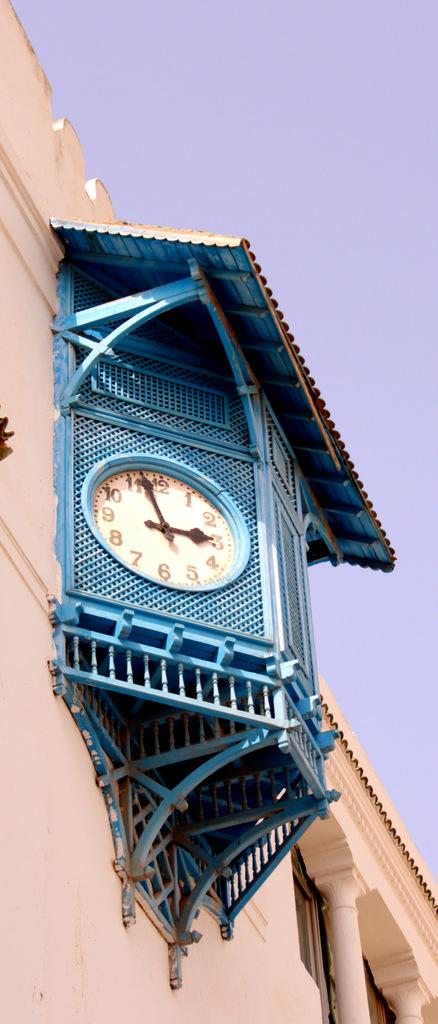<image>
Offer a succinct explanation of the picture presented. a clock that has the letter 12 at the top 